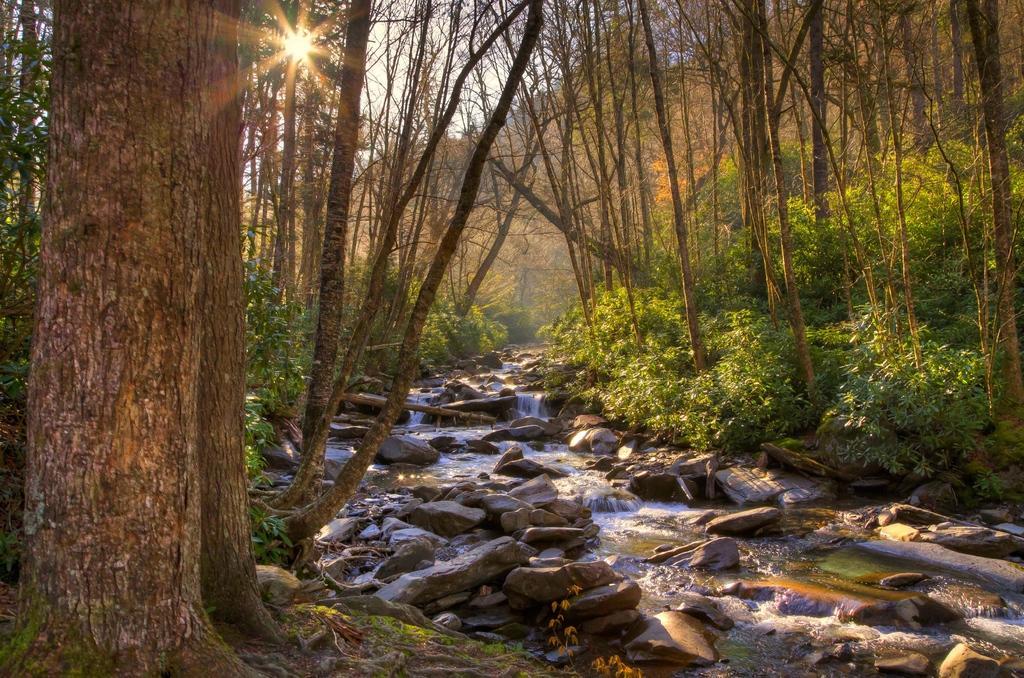Please provide a concise description of this image. These are the trees, in the middle water is flowing. 